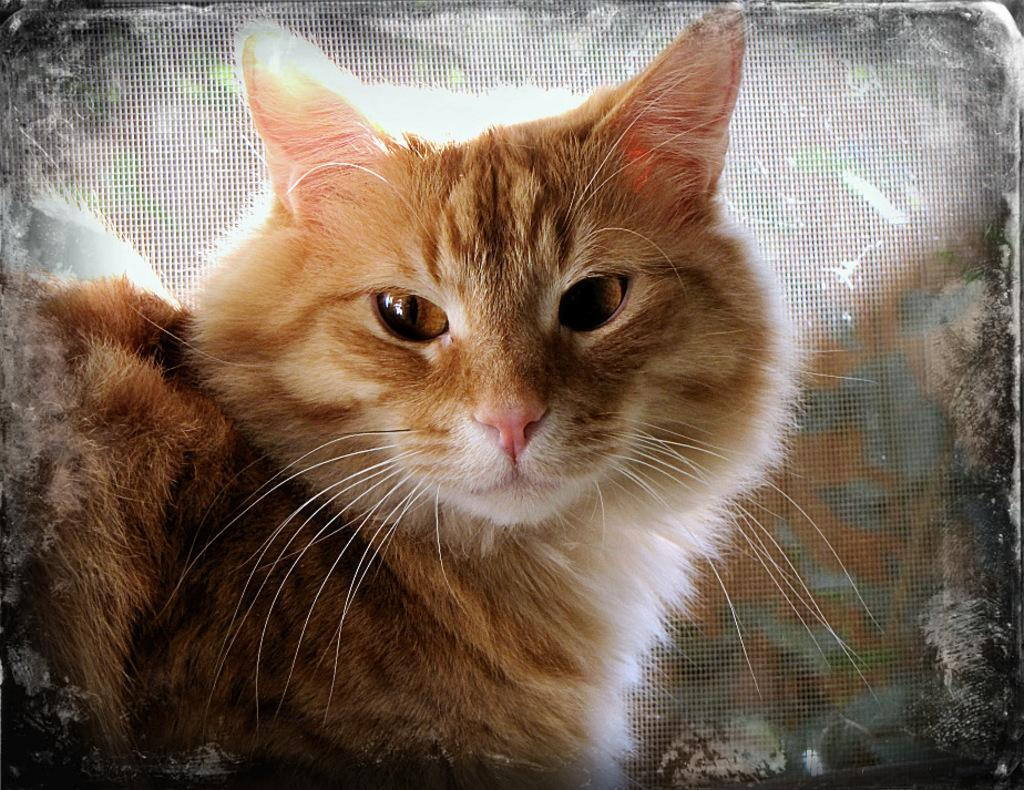What type of animal is in the image? There is a cat in the image. Where is the cat located in the image? The cat is towards the left side of the image. What color is the cat? The cat is brown in color. What can be seen in the background of the image? There is a mesh in the background of the image. What type of train is passing by in the image? There is no train present in the image; it features a cat and a mesh background. 